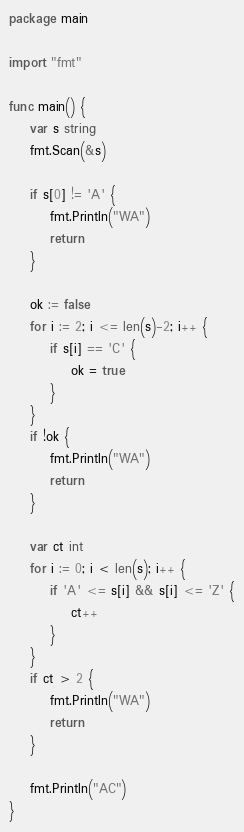<code> <loc_0><loc_0><loc_500><loc_500><_Go_>package main

import "fmt"

func main() {
	var s string
	fmt.Scan(&s)

	if s[0] != 'A' {
		fmt.Println("WA")
		return
	}

	ok := false
	for i := 2; i <= len(s)-2; i++ {
		if s[i] == 'C' {
			ok = true
		}
	}
	if !ok {
		fmt.Println("WA")
		return
	}

	var ct int
	for i := 0; i < len(s); i++ {
		if 'A' <= s[i] && s[i] <= 'Z' {
			ct++
		}
	}
	if ct > 2 {
		fmt.Println("WA")
		return
	}

	fmt.Println("AC")
}
</code> 